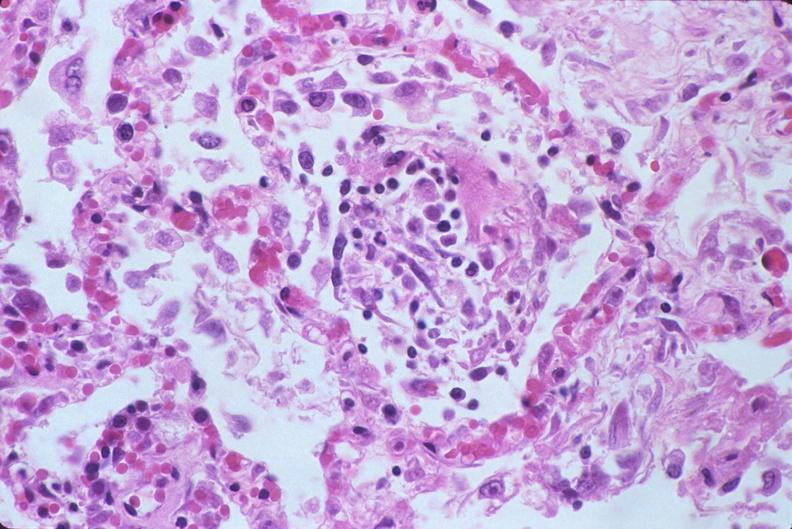s respiratory present?
Answer the question using a single word or phrase. Yes 